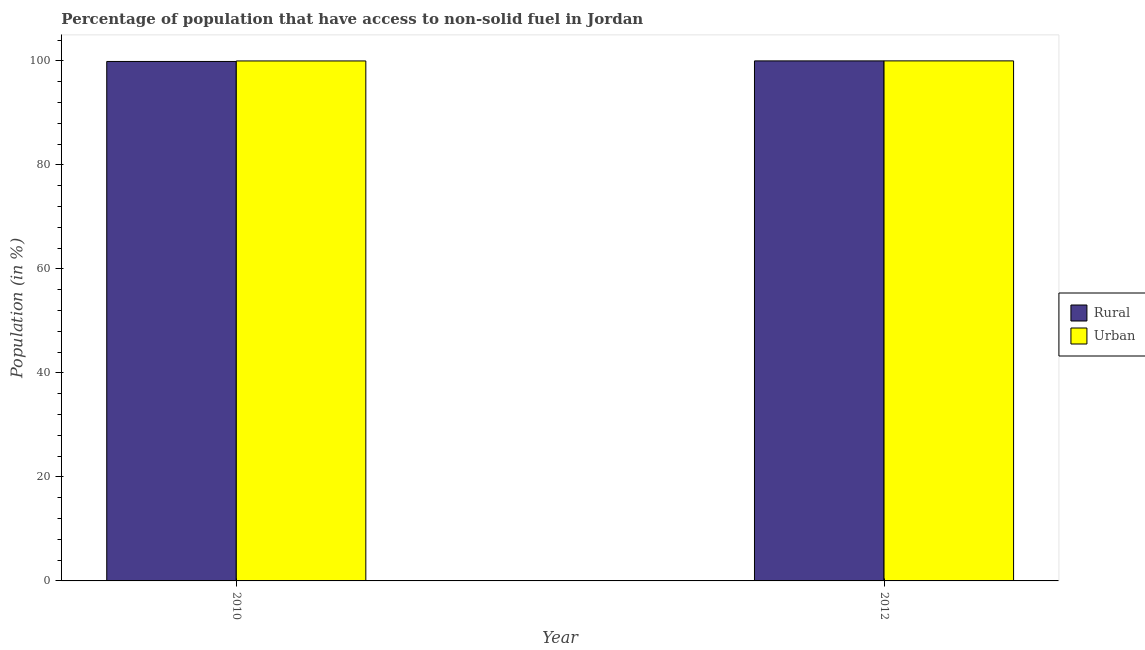Are the number of bars per tick equal to the number of legend labels?
Ensure brevity in your answer.  Yes. What is the label of the 2nd group of bars from the left?
Provide a short and direct response. 2012. What is the rural population in 2012?
Provide a short and direct response. 99.99. Across all years, what is the maximum rural population?
Keep it short and to the point. 99.99. Across all years, what is the minimum rural population?
Provide a short and direct response. 99.88. What is the total urban population in the graph?
Your answer should be compact. 199.97. What is the difference between the rural population in 2010 and that in 2012?
Your answer should be very brief. -0.11. What is the difference between the rural population in 2012 and the urban population in 2010?
Your answer should be very brief. 0.11. What is the average urban population per year?
Make the answer very short. 99.98. In how many years, is the urban population greater than 68 %?
Provide a succinct answer. 2. What is the ratio of the urban population in 2010 to that in 2012?
Offer a very short reply. 1. What does the 1st bar from the left in 2012 represents?
Your answer should be compact. Rural. What does the 2nd bar from the right in 2012 represents?
Provide a short and direct response. Rural. Are all the bars in the graph horizontal?
Offer a terse response. No. How many years are there in the graph?
Make the answer very short. 2. What is the difference between two consecutive major ticks on the Y-axis?
Keep it short and to the point. 20. Are the values on the major ticks of Y-axis written in scientific E-notation?
Your answer should be very brief. No. Does the graph contain any zero values?
Make the answer very short. No. Where does the legend appear in the graph?
Offer a very short reply. Center right. What is the title of the graph?
Offer a terse response. Percentage of population that have access to non-solid fuel in Jordan. What is the Population (in %) of Rural in 2010?
Provide a succinct answer. 99.88. What is the Population (in %) in Urban in 2010?
Keep it short and to the point. 99.98. What is the Population (in %) in Rural in 2012?
Provide a short and direct response. 99.99. What is the Population (in %) in Urban in 2012?
Keep it short and to the point. 99.99. Across all years, what is the maximum Population (in %) of Rural?
Your answer should be very brief. 99.99. Across all years, what is the maximum Population (in %) in Urban?
Give a very brief answer. 99.99. Across all years, what is the minimum Population (in %) in Rural?
Make the answer very short. 99.88. Across all years, what is the minimum Population (in %) in Urban?
Your answer should be compact. 99.98. What is the total Population (in %) of Rural in the graph?
Your answer should be compact. 199.87. What is the total Population (in %) of Urban in the graph?
Keep it short and to the point. 199.97. What is the difference between the Population (in %) of Rural in 2010 and that in 2012?
Offer a very short reply. -0.11. What is the difference between the Population (in %) of Urban in 2010 and that in 2012?
Your answer should be very brief. -0.01. What is the difference between the Population (in %) of Rural in 2010 and the Population (in %) of Urban in 2012?
Provide a short and direct response. -0.11. What is the average Population (in %) in Rural per year?
Offer a very short reply. 99.93. What is the average Population (in %) in Urban per year?
Your response must be concise. 99.98. In the year 2010, what is the difference between the Population (in %) in Rural and Population (in %) in Urban?
Offer a terse response. -0.1. In the year 2012, what is the difference between the Population (in %) of Rural and Population (in %) of Urban?
Ensure brevity in your answer.  -0. What is the difference between the highest and the second highest Population (in %) in Rural?
Make the answer very short. 0.11. What is the difference between the highest and the second highest Population (in %) of Urban?
Offer a very short reply. 0.01. What is the difference between the highest and the lowest Population (in %) of Rural?
Offer a terse response. 0.11. What is the difference between the highest and the lowest Population (in %) in Urban?
Offer a terse response. 0.01. 